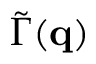<formula> <loc_0><loc_0><loc_500><loc_500>\widetilde { \Gamma } ( q )</formula> 